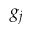<formula> <loc_0><loc_0><loc_500><loc_500>g _ { j }</formula> 